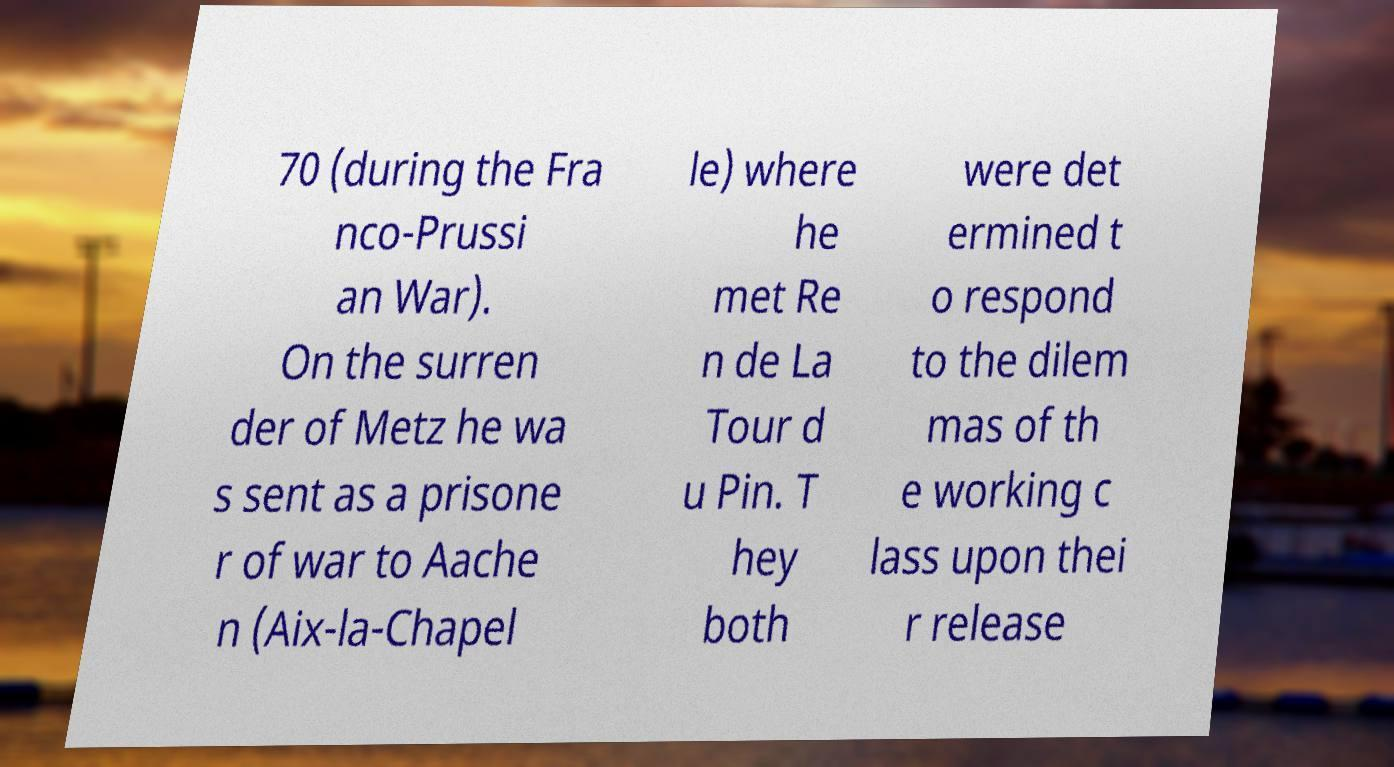Please identify and transcribe the text found in this image. 70 (during the Fra nco-Prussi an War). On the surren der of Metz he wa s sent as a prisone r of war to Aache n (Aix-la-Chapel le) where he met Re n de La Tour d u Pin. T hey both were det ermined t o respond to the dilem mas of th e working c lass upon thei r release 